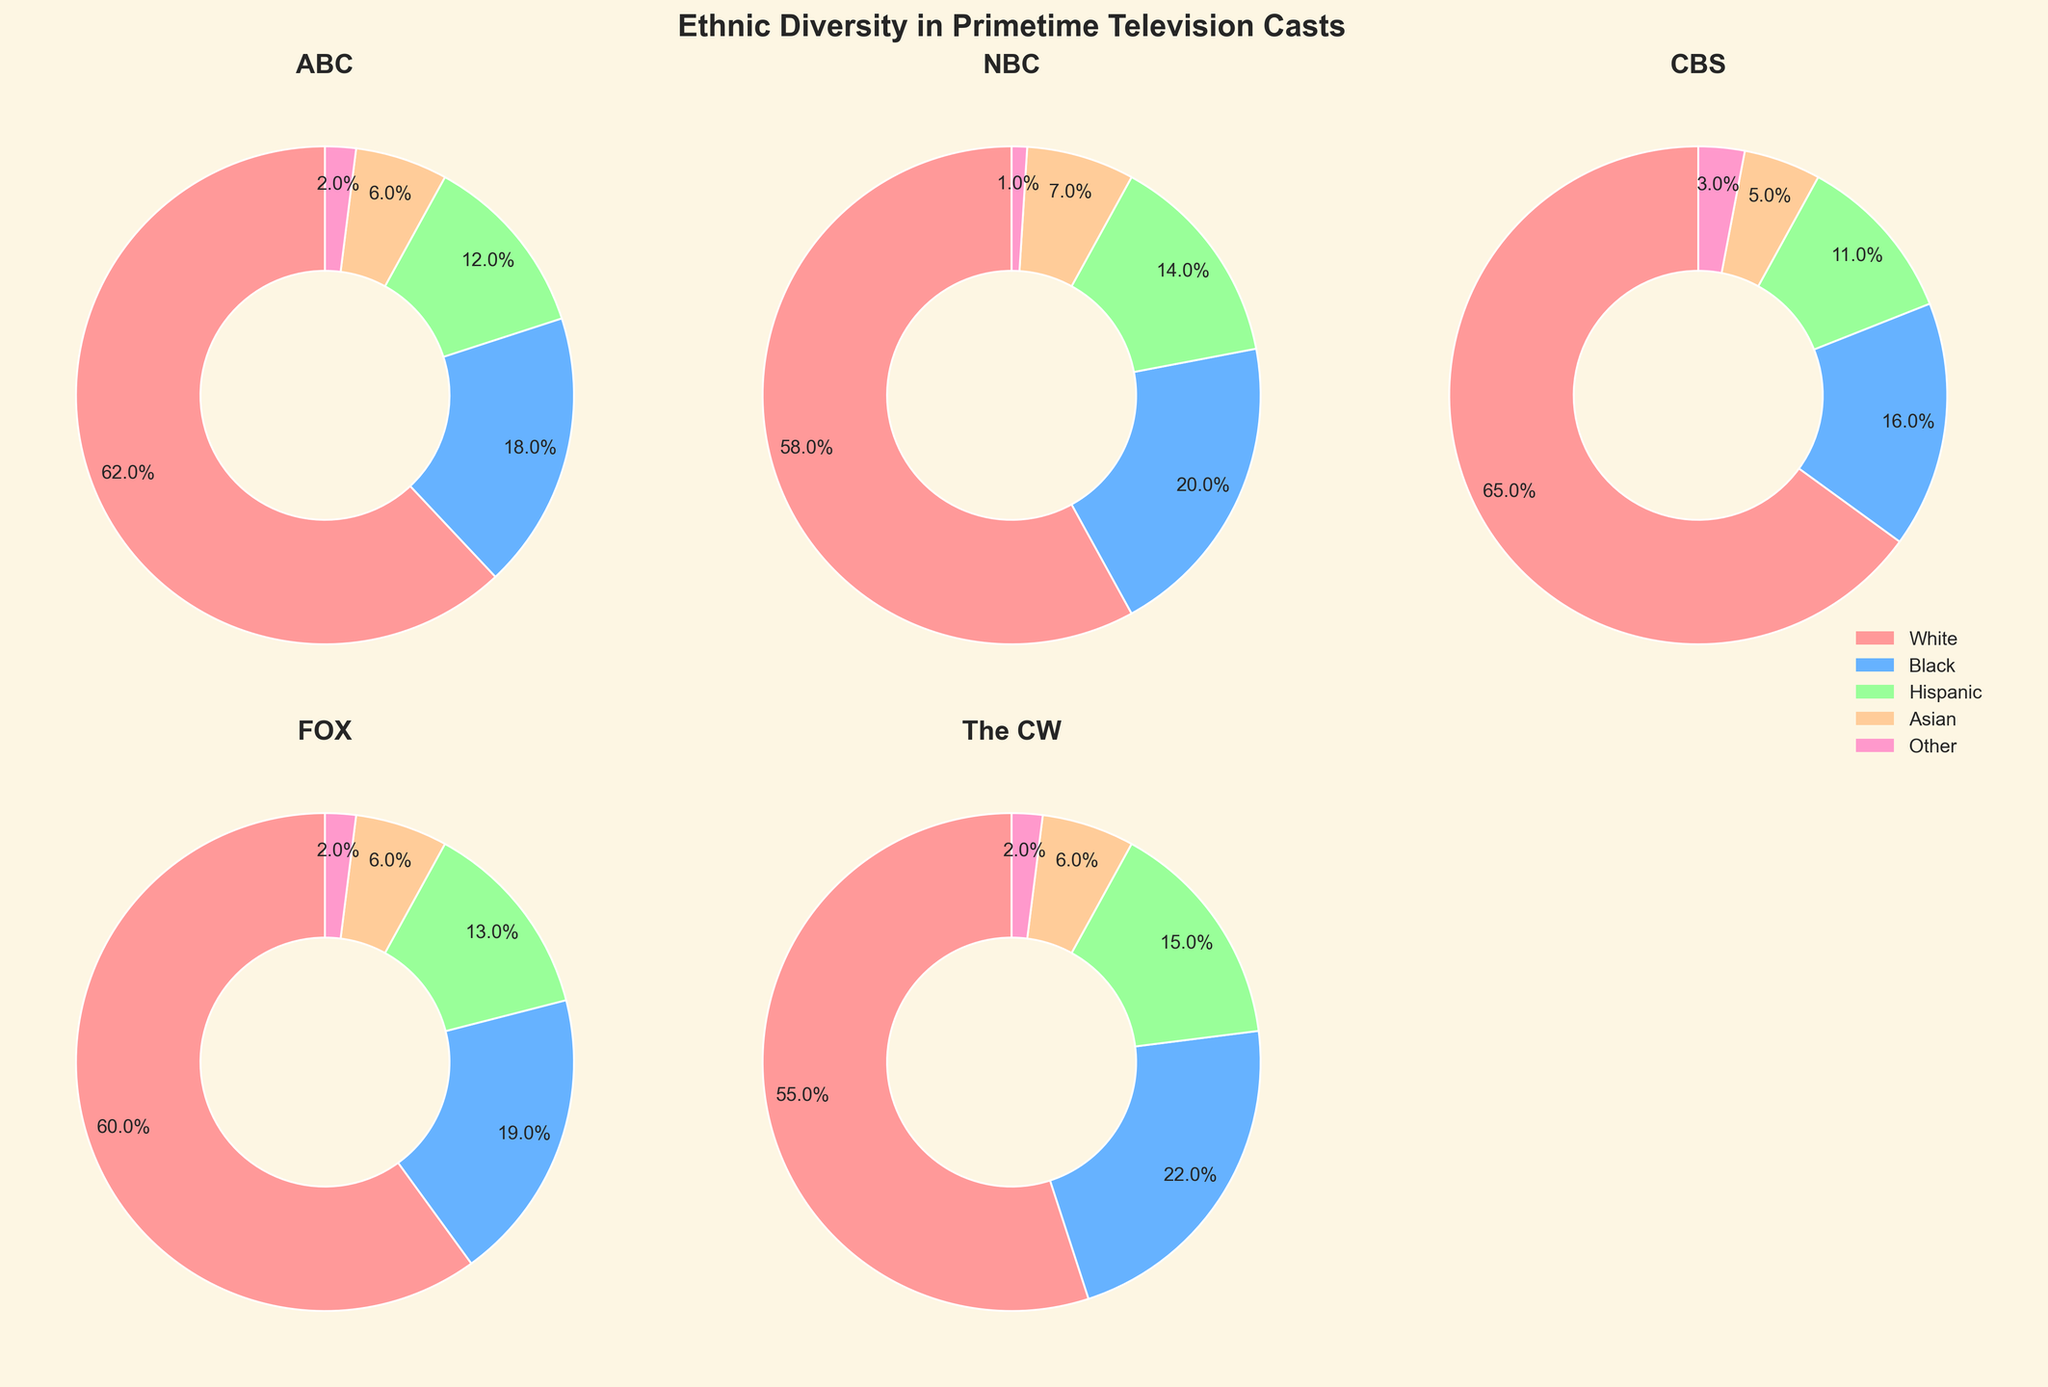What is the title of the figure? The title is visible at the top of the figure as it summarizes the entire plot. The text reads "Ethnic Diversity in Primetime Television Casts".
Answer: Ethnic Diversity in Primetime Television Casts Which network has the highest percentage of Hispanic cast members? By looking at the pie charts for each network, we can see that The CW has the highest slice of the pie for Hispanic cast members, labeled with percentage values.
Answer: The CW How many ethnic categories are included in the figure? There are five slices in each pie chart, and a legend on the right indicates the categories: White, Black, Hispanic, Asian, and Other.
Answer: Five What is the average percentage of White cast members across all networks? Add the percentages of White cast members for each network (62, 58, 65, 60, 55) and divide by the number of networks (5). The calculation is (62 + 58 + 65 + 60 + 55) / 5.
Answer: 60% Which network has the lowest percentage of Black cast members? By comparing the pie charts, we see that CBS has the smallest slice for Black cast members at 16%.
Answer: CBS Which network has the most even distribution among the five ethnic categories? Evaluate the pie charts to see which has slices of roughly equal size. The CW appears to have the most balanced distribution.
Answer: The CW If we sum the percentages of Asian cast members across all networks, what is the total? Add the percentages of Asian cast members for each network (6, 7, 5, 6, 6). The calculation is 6 + 7 + 5 + 6 + 6.
Answer: 30% Which two ethnic categories combined make up the majority of the cast for ABC? For ABC, the two largest slices are White (62%) and Black (18%). The sum is 62% + 18% = 80%, which is the majority.
Answer: White and Black How does the percentage of 'Other' ethnic category compare across NBC and FOX? Look at the slices labeled 'Other' for NBC and FOX. NBC has 1% and FOX has 2%, so FOX is higher.
Answer: FOX is higher What is the percentage range of Black cast members across all networks? Identify the minimum and maximum percentages among the networks for Black cast members. The minimum is 16% (CBS) and the maximum is 22% (The CW), so the range is 22% - 16% = 6%.
Answer: 6% 